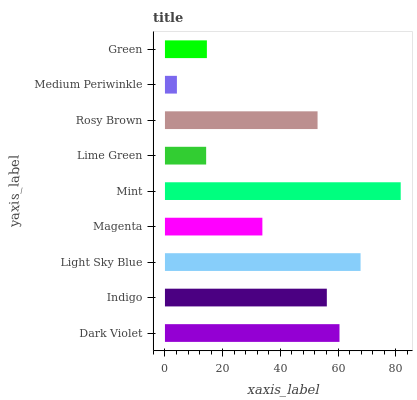Is Medium Periwinkle the minimum?
Answer yes or no. Yes. Is Mint the maximum?
Answer yes or no. Yes. Is Indigo the minimum?
Answer yes or no. No. Is Indigo the maximum?
Answer yes or no. No. Is Dark Violet greater than Indigo?
Answer yes or no. Yes. Is Indigo less than Dark Violet?
Answer yes or no. Yes. Is Indigo greater than Dark Violet?
Answer yes or no. No. Is Dark Violet less than Indigo?
Answer yes or no. No. Is Rosy Brown the high median?
Answer yes or no. Yes. Is Rosy Brown the low median?
Answer yes or no. Yes. Is Magenta the high median?
Answer yes or no. No. Is Indigo the low median?
Answer yes or no. No. 